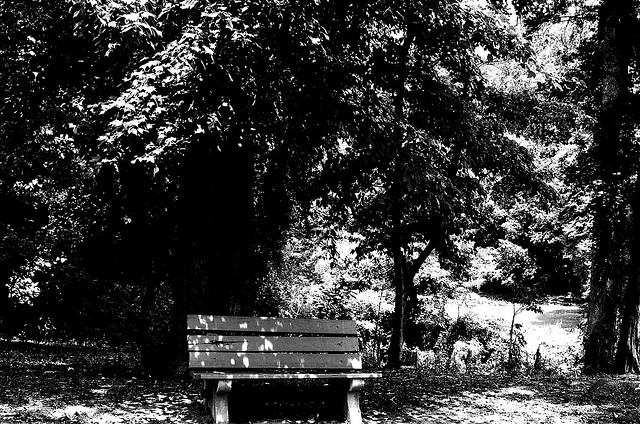<image>Is this downtown? I am not sure if this is downtown. Is this downtown? I am not sure if this is downtown. It can be seen that it is not downtown. 